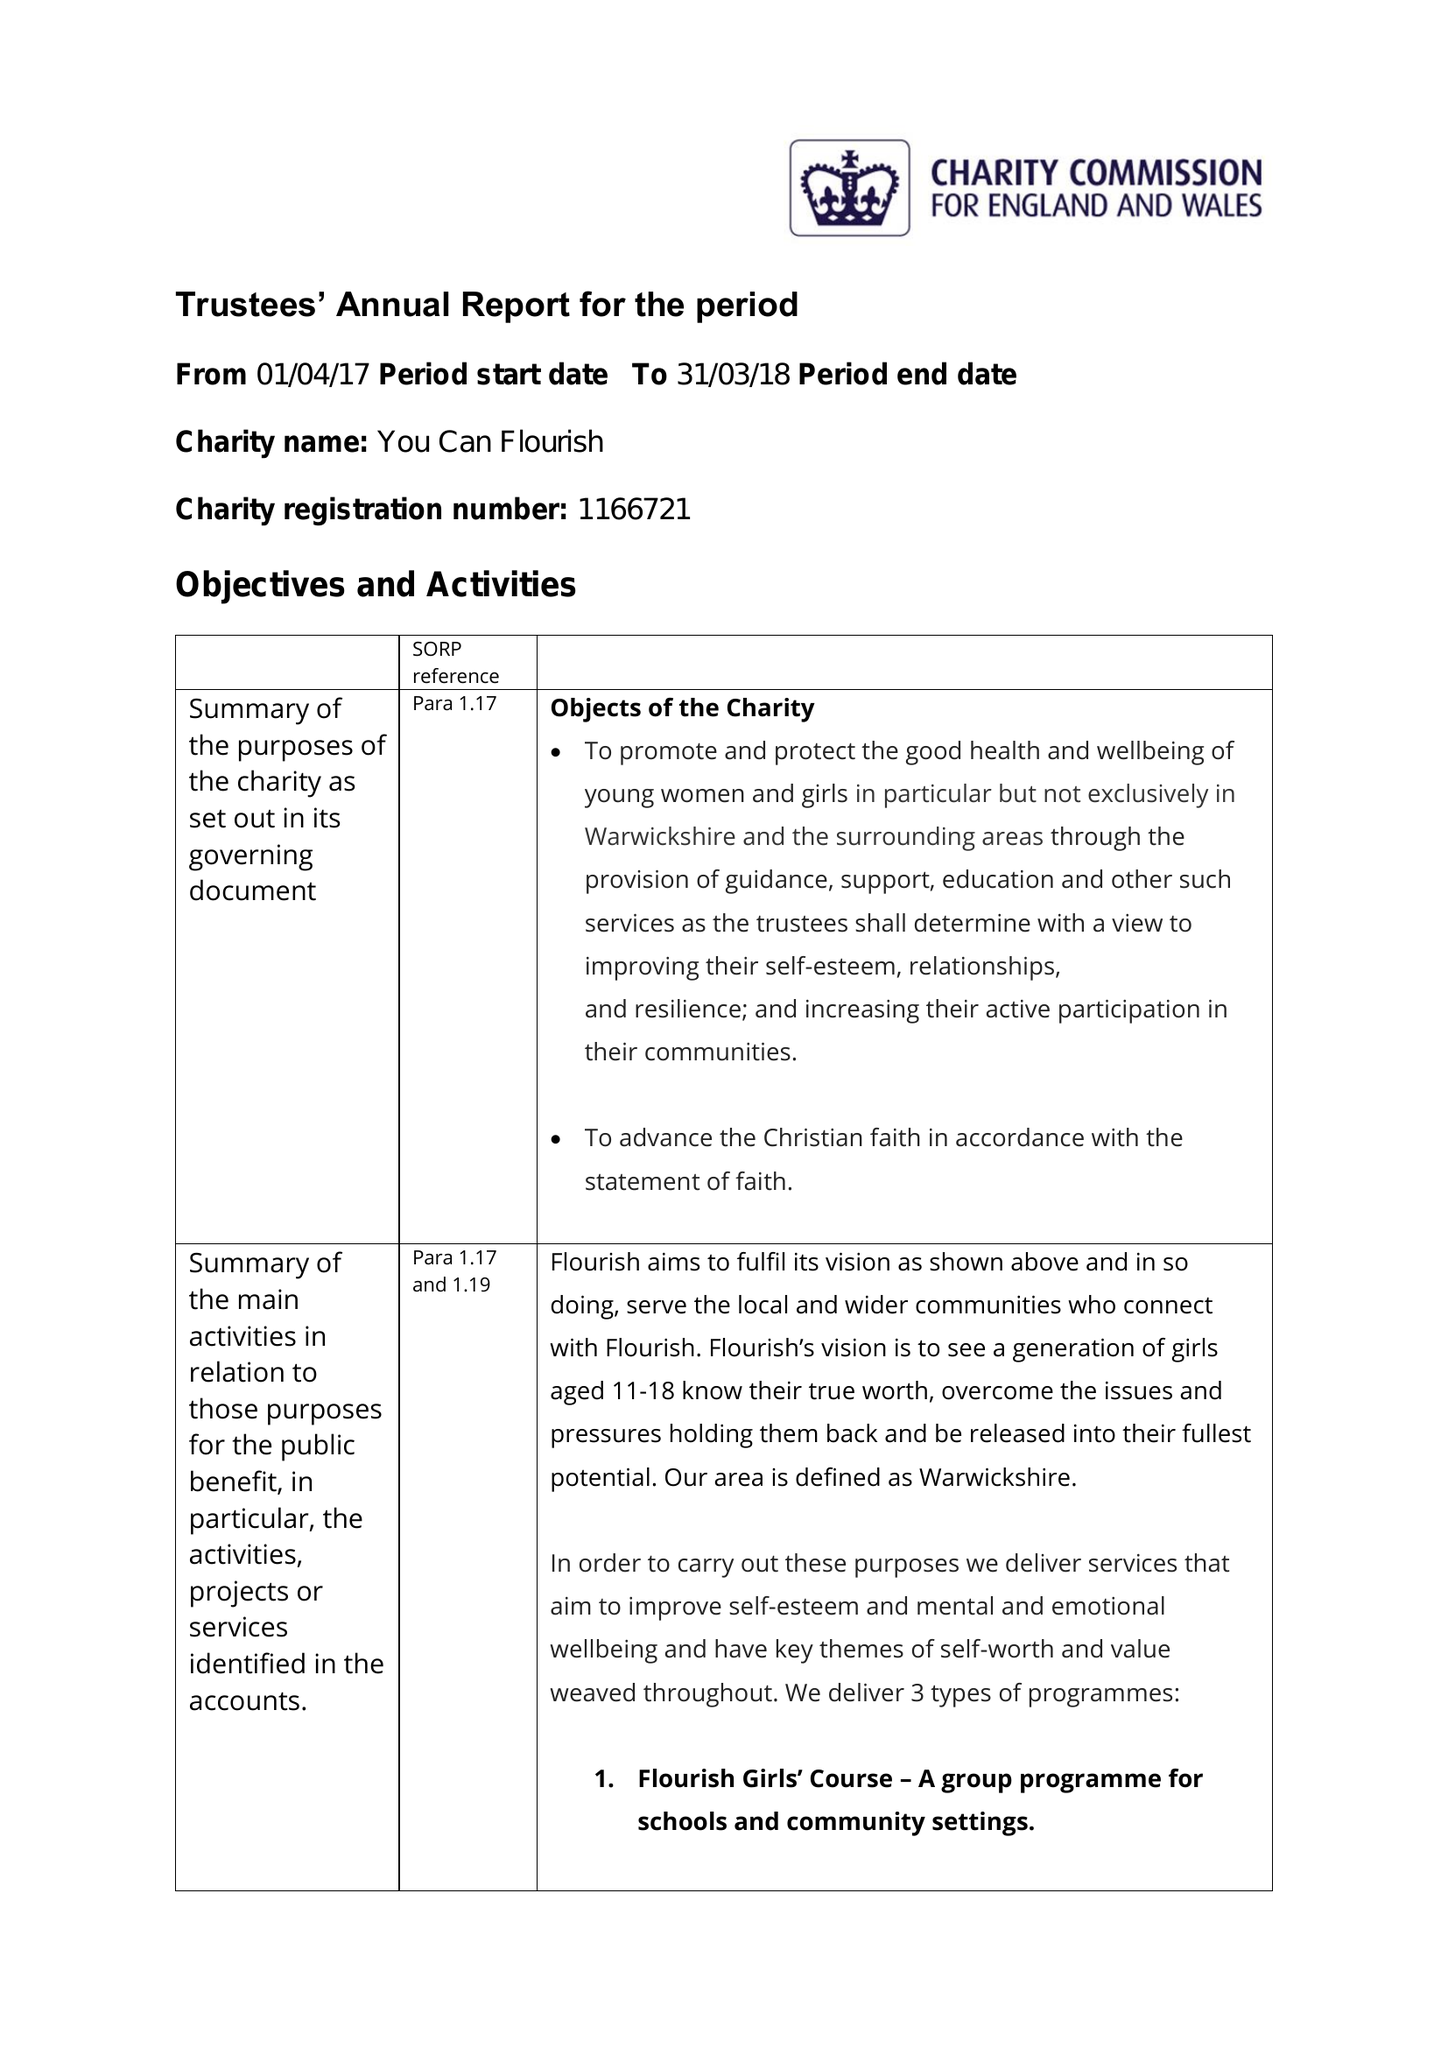What is the value for the report_date?
Answer the question using a single word or phrase. 2018-03-31 